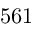<formula> <loc_0><loc_0><loc_500><loc_500>5 6 1</formula> 